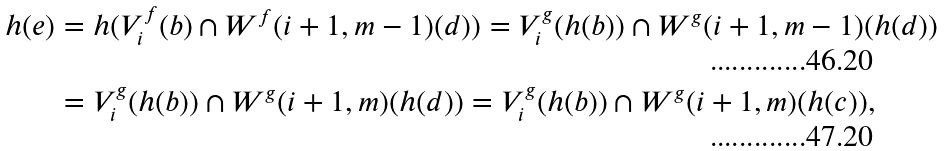Convert formula to latex. <formula><loc_0><loc_0><loc_500><loc_500>h ( e ) & = h ( V _ { i } ^ { f } ( b ) \cap W ^ { f } ( i + 1 , m - 1 ) ( d ) ) = V _ { i } ^ { g } ( h ( b ) ) \cap W ^ { g } ( i + 1 , m - 1 ) ( h ( d ) ) \\ & = V _ { i } ^ { g } ( h ( b ) ) \cap W ^ { g } ( i + 1 , m ) ( h ( d ) ) = V _ { i } ^ { g } ( h ( b ) ) \cap W ^ { g } ( i + 1 , m ) ( h ( c ) ) ,</formula> 